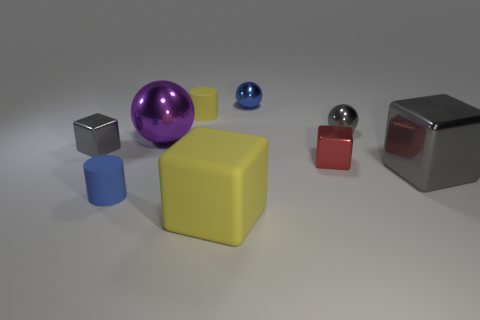There is a matte block; does it have the same color as the big thing to the left of the big yellow object?
Keep it short and to the point. No. How many other things are the same size as the blue cylinder?
Provide a short and direct response. 5. What is the size of the other rubber thing that is the same color as the big rubber object?
Provide a short and direct response. Small. How many balls are tiny gray things or large matte objects?
Keep it short and to the point. 1. Is the shape of the tiny gray metal object that is to the left of the large rubber object the same as  the large matte thing?
Give a very brief answer. Yes. Are there more blue cylinders behind the tiny blue matte object than tiny gray blocks?
Your answer should be very brief. No. What is the color of the metal block that is the same size as the yellow matte block?
Your answer should be compact. Gray. What number of objects are either yellow rubber objects that are behind the red shiny thing or red things?
Give a very brief answer. 2. There is a small matte object that is the same color as the big rubber thing; what is its shape?
Your answer should be very brief. Cylinder. What material is the block that is in front of the large shiny thing right of the large yellow matte object made of?
Keep it short and to the point. Rubber. 